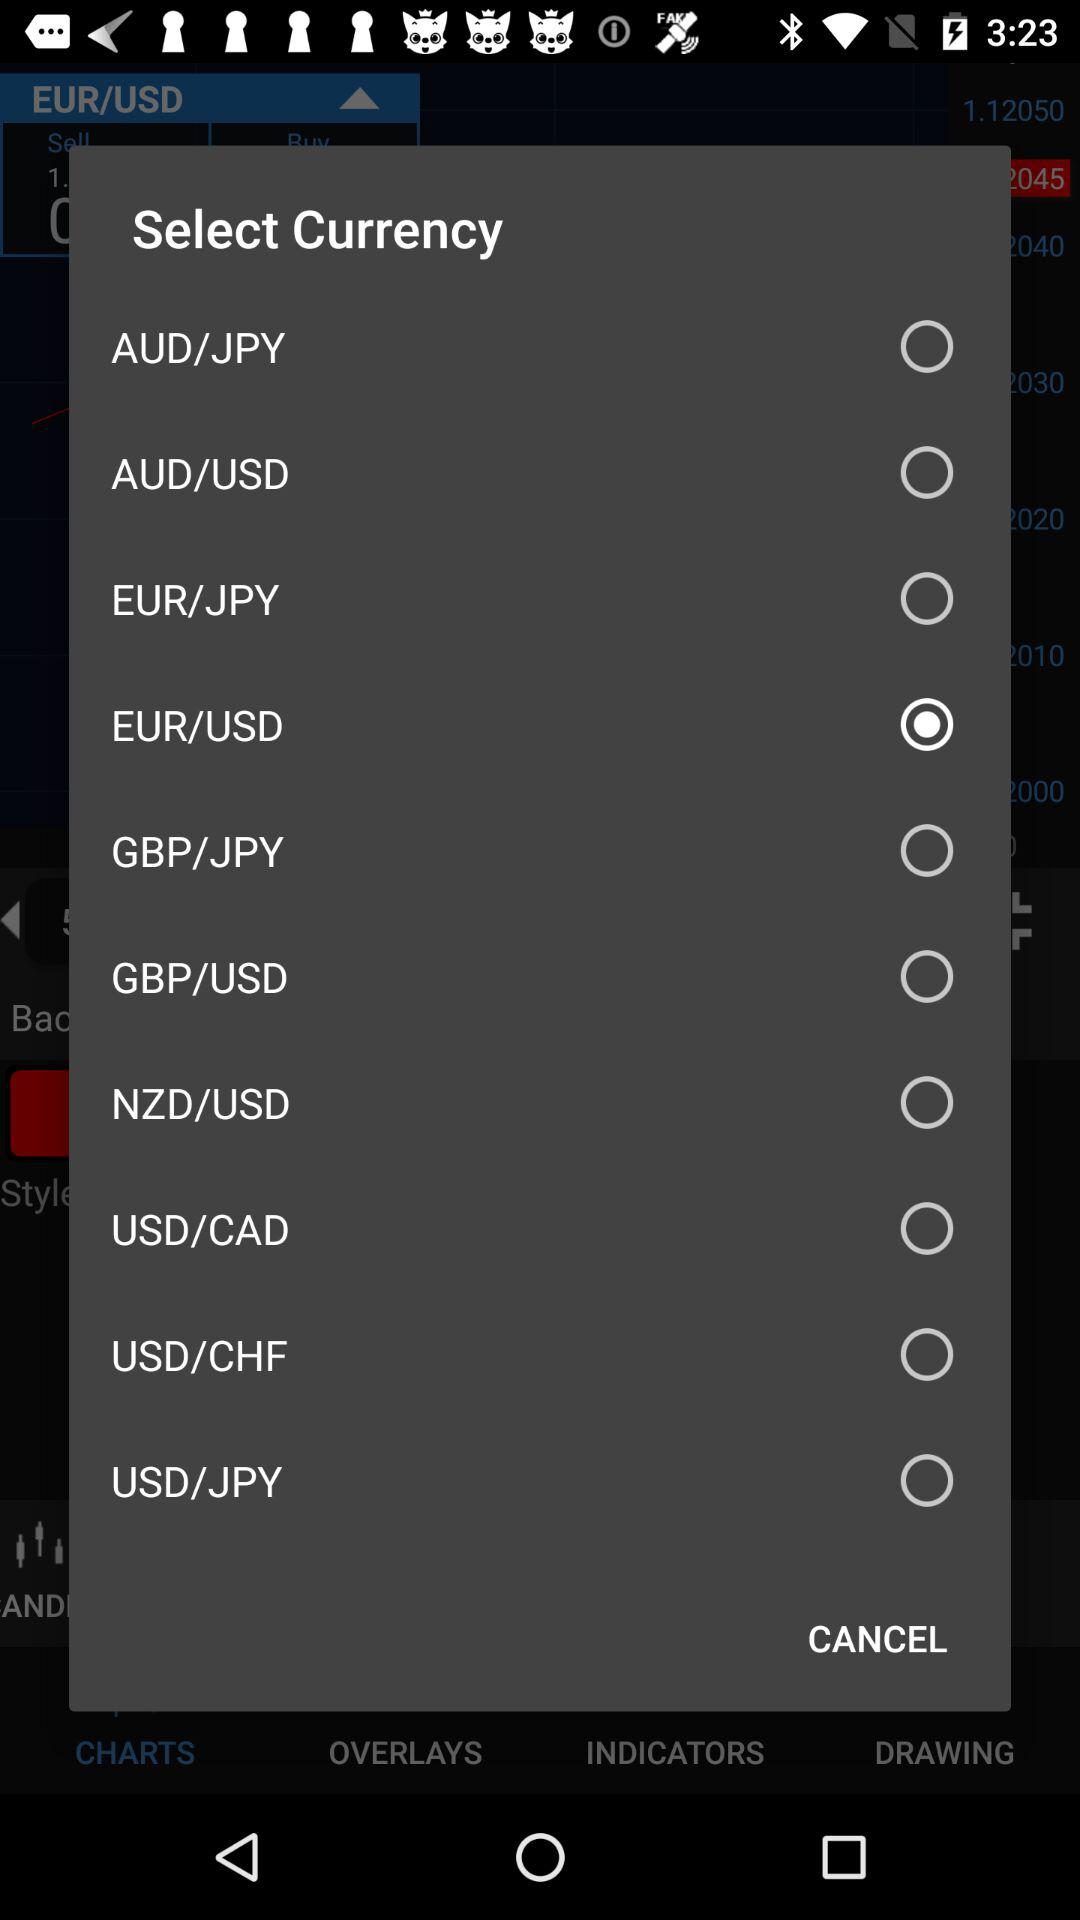Which currency is selected? The selected currency is "EUR/USD". 